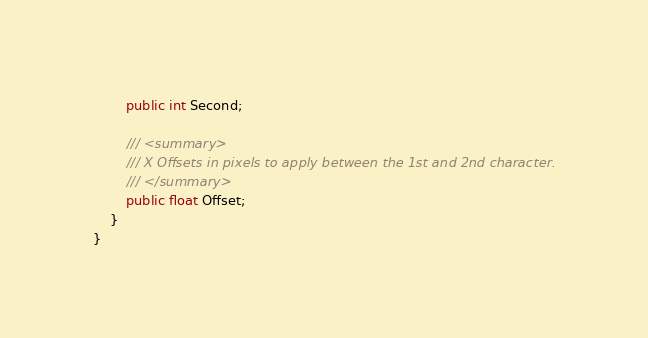Convert code to text. <code><loc_0><loc_0><loc_500><loc_500><_C#_>        public int Second;

        /// <summary>
        /// X Offsets in pixels to apply between the 1st and 2nd character.
        /// </summary>
        public float Offset;
    }
}
</code> 